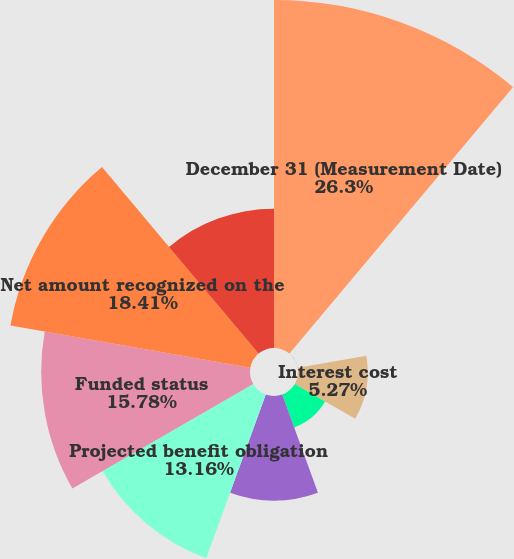<chart> <loc_0><loc_0><loc_500><loc_500><pie_chart><fcel>December 31 (Measurement Date)<fcel>Service cost<fcel>Interest cost<fcel>Actuarial loss (gain)<fcel>Benefits paid<fcel>Projected benefit obligation<fcel>Funded status<fcel>Net amount recognized on the<fcel>Net actuarial loss<nl><fcel>26.3%<fcel>0.01%<fcel>5.27%<fcel>2.64%<fcel>7.9%<fcel>13.16%<fcel>15.78%<fcel>18.41%<fcel>10.53%<nl></chart> 